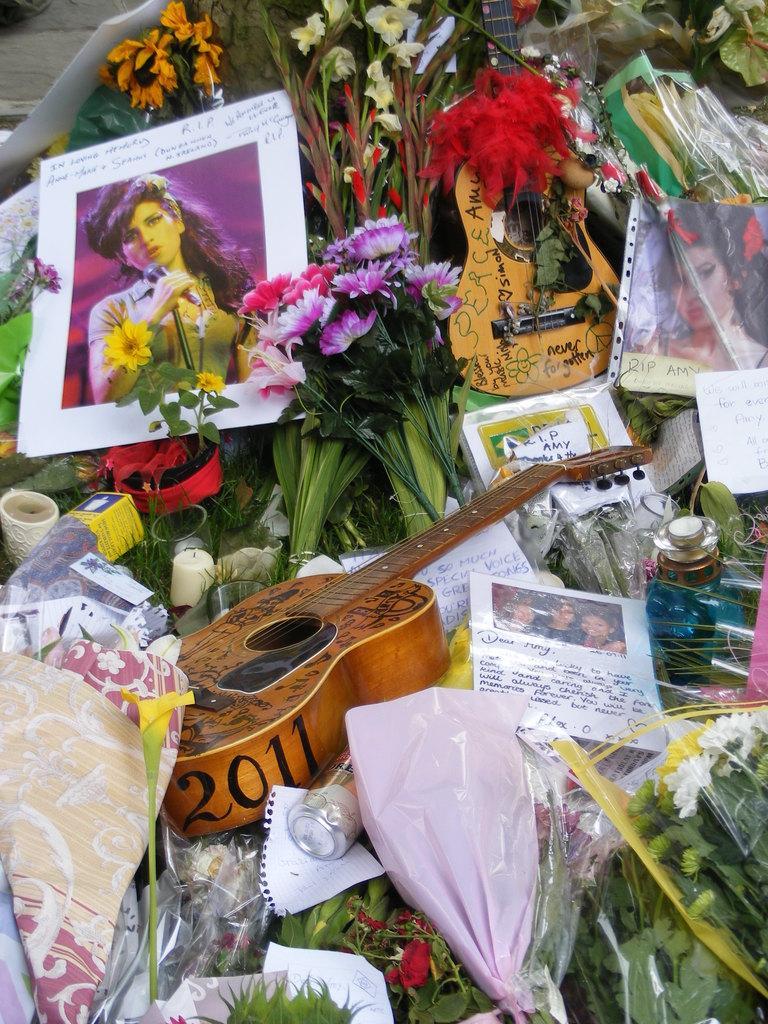Please provide a concise description of this image. This image seems like it is a combination of flowers,guitars,photos,papers and decorative items. 